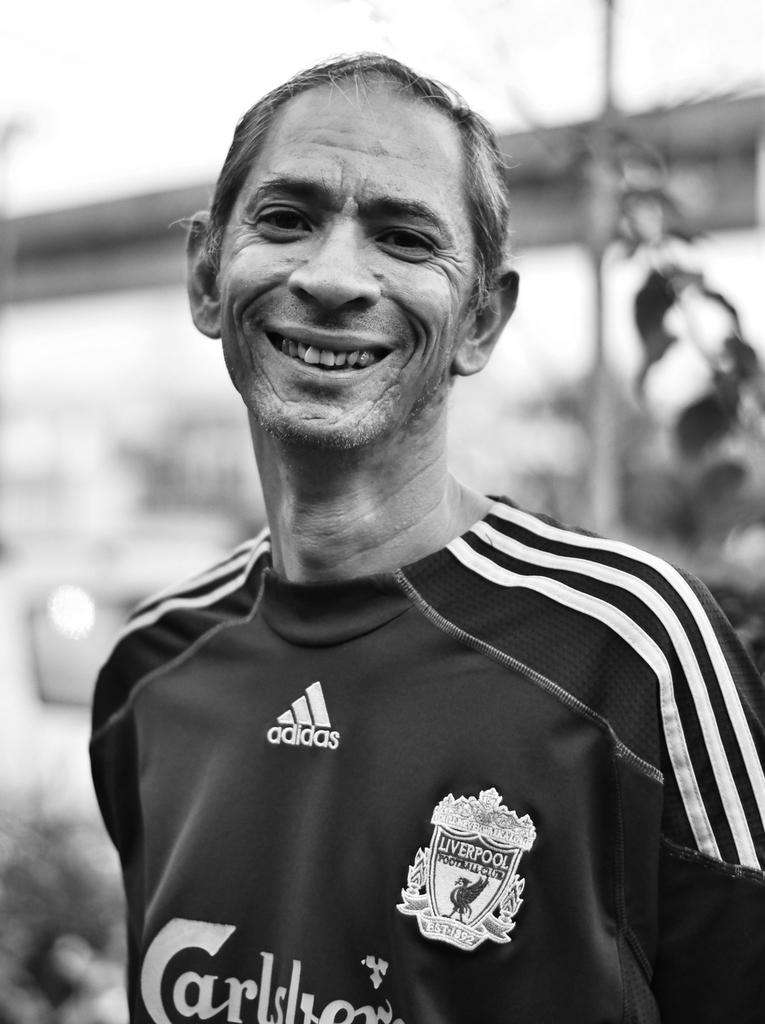<image>
Describe the image concisely. A man in a Liverpool jersey has stripes on his shoulders. 